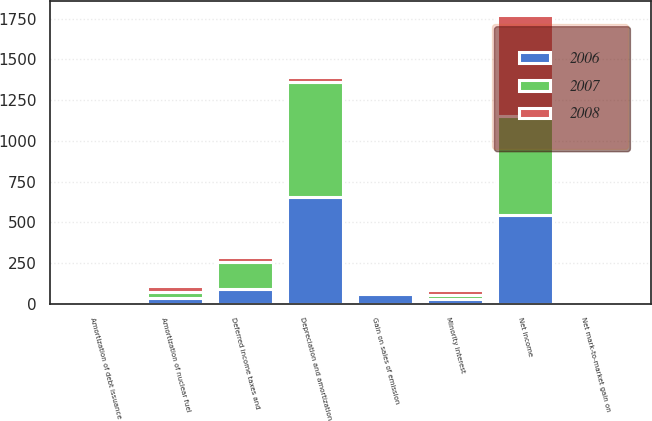Convert chart to OTSL. <chart><loc_0><loc_0><loc_500><loc_500><stacked_bar_chart><ecel><fcel>Net income<fcel>Gain on sales of emission<fcel>Net mark-to-market gain on<fcel>Depreciation and amortization<fcel>Amortization of nuclear fuel<fcel>Amortization of debt issuance<fcel>Deferred income taxes and<fcel>Minority interest<nl><fcel>2007<fcel>605<fcel>8<fcel>3<fcel>705<fcel>37<fcel>20<fcel>167<fcel>29<nl><fcel>2008<fcel>618<fcel>8<fcel>3<fcel>29<fcel>37<fcel>19<fcel>28<fcel>27<nl><fcel>2006<fcel>547<fcel>60<fcel>2<fcel>656<fcel>36<fcel>15<fcel>91<fcel>27<nl></chart> 